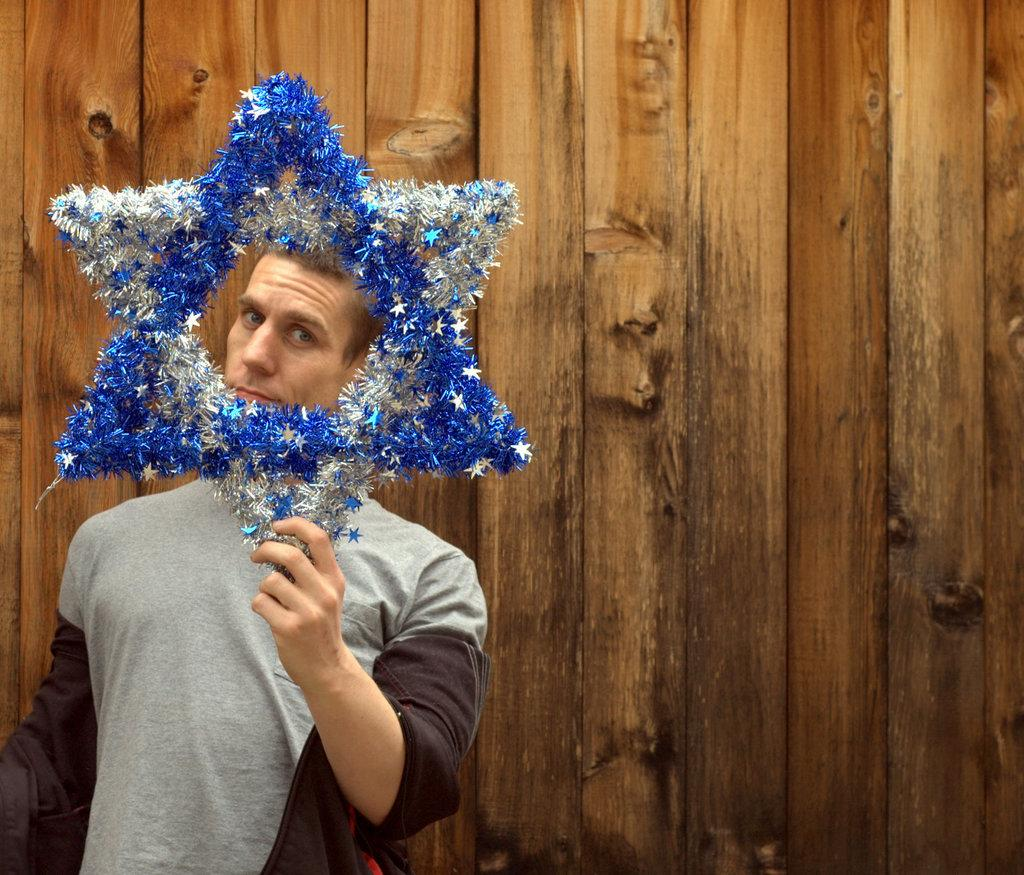Who is present in the image? There is a man in the image. What is the man holding in the image? The man is holding a star. What type of clothing is the man wearing? The man is wearing a t-shirt. What can be seen in the background of the image? There is a wooden wall in the background of the image. Can you see the man riding a bike in the image? No, there is no bike present in the image. 